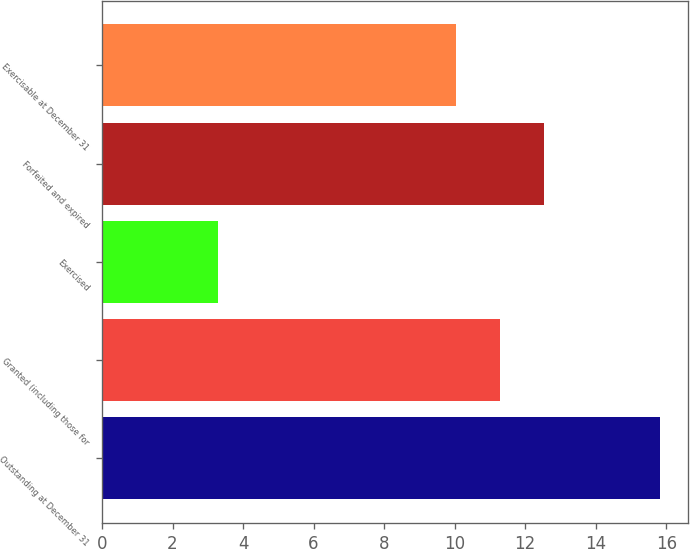Convert chart. <chart><loc_0><loc_0><loc_500><loc_500><bar_chart><fcel>Outstanding at December 31<fcel>Granted (including those for<fcel>Exercised<fcel>Forfeited and expired<fcel>Exercisable at December 31<nl><fcel>15.83<fcel>11.29<fcel>3.28<fcel>12.54<fcel>10.03<nl></chart> 